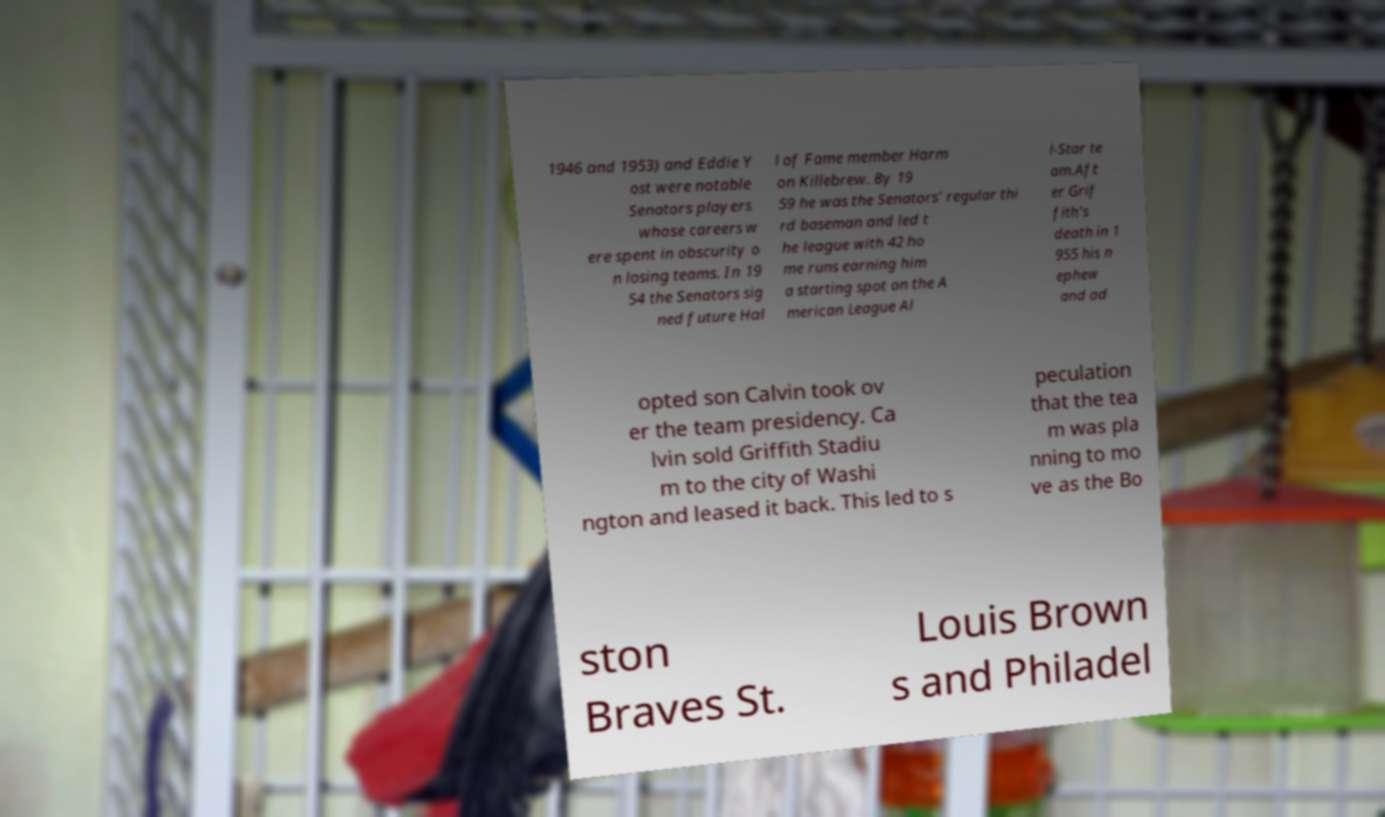For documentation purposes, I need the text within this image transcribed. Could you provide that? 1946 and 1953) and Eddie Y ost were notable Senators players whose careers w ere spent in obscurity o n losing teams. In 19 54 the Senators sig ned future Hal l of Fame member Harm on Killebrew. By 19 59 he was the Senators’ regular thi rd baseman and led t he league with 42 ho me runs earning him a starting spot on the A merican League Al l-Star te am.Aft er Grif fith's death in 1 955 his n ephew and ad opted son Calvin took ov er the team presidency. Ca lvin sold Griffith Stadiu m to the city of Washi ngton and leased it back. This led to s peculation that the tea m was pla nning to mo ve as the Bo ston Braves St. Louis Brown s and Philadel 